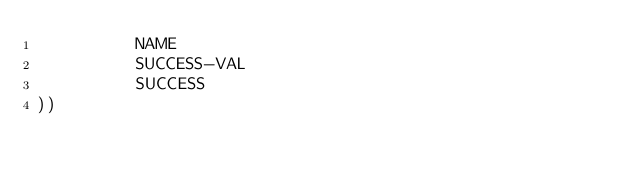Convert code to text. <code><loc_0><loc_0><loc_500><loc_500><_Lisp_>          NAME
          SUCCESS-VAL
          SUCCESS
))</code> 